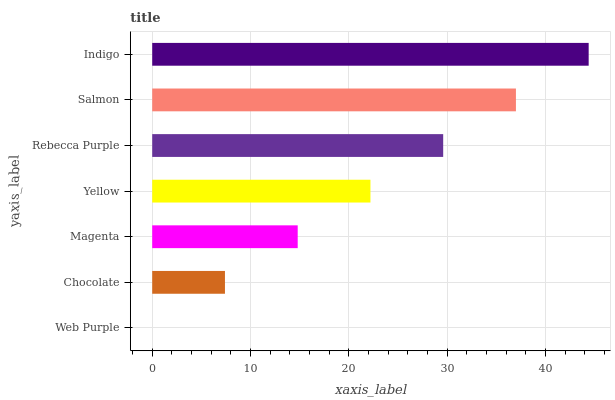Is Web Purple the minimum?
Answer yes or no. Yes. Is Indigo the maximum?
Answer yes or no. Yes. Is Chocolate the minimum?
Answer yes or no. No. Is Chocolate the maximum?
Answer yes or no. No. Is Chocolate greater than Web Purple?
Answer yes or no. Yes. Is Web Purple less than Chocolate?
Answer yes or no. Yes. Is Web Purple greater than Chocolate?
Answer yes or no. No. Is Chocolate less than Web Purple?
Answer yes or no. No. Is Yellow the high median?
Answer yes or no. Yes. Is Yellow the low median?
Answer yes or no. Yes. Is Salmon the high median?
Answer yes or no. No. Is Magenta the low median?
Answer yes or no. No. 